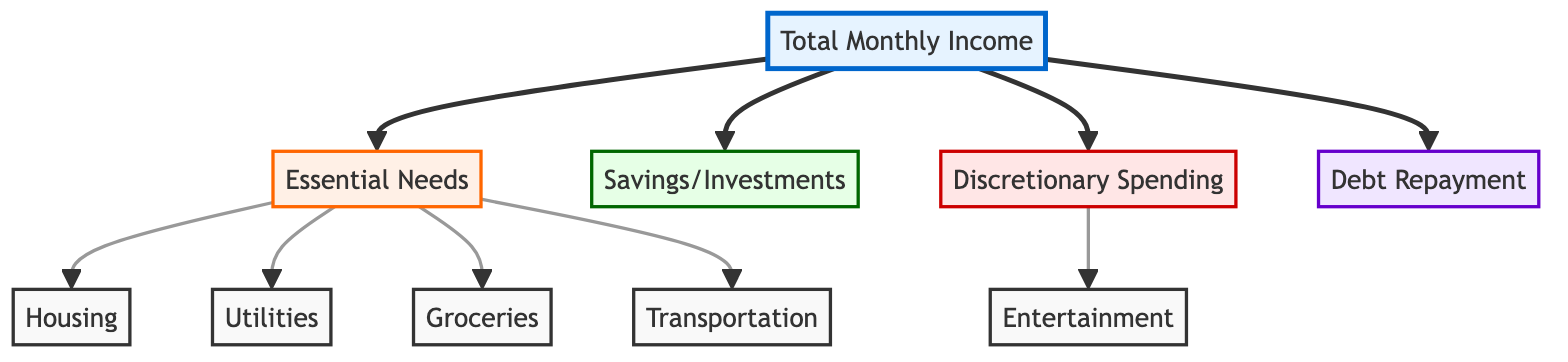What is the total number of nodes in this diagram? The diagram contains a total of 10 nodes, which are Total Monthly Income, Essential Needs, Housing, Utilities, Groceries, Transportation, Savings/Investments, Discretionary Spending, Entertainment, and Debt Repayment.
Answer: 10 Which node indicates essential needs? The node labeled "Essential Needs" represents the basic necessity category for household expenses. In the diagram, it is directly connected to Total Monthly Income.
Answer: Essential Needs How many edges are connected to the "Income" node? The "Income" node has 4 edges connected to it, leading to the nodes "Needs," "Savings," "Discretionary," and "Debt." This indicates the different allocations of income.
Answer: 4 What node is directly connected to "Discretionary Spending"? The node "Entertainment" is directly connected to "Discretionary Spending," displaying that entertainment expenses fall under this discretionary category.
Answer: Entertainment What type of spending does the "Housing" node represent? The "Housing" node represents essential need spending for household financial planning, specifically in terms of rent or mortgage payments.
Answer: Housing Which two nodes have a direct relationship indicating a breakdown of needs? The nodes "Essential Needs" and "Housing" have a direct relationship, with "Housing" categorized under "Essential Needs," showing that housing costs are an essential need.
Answer: Essential Needs and Housing What is the direction of flow from "Income" to "Savings"? The direction of flow from "Income" to "Savings" is depicted with an arrow starting from "Income" pointing towards "Savings," demonstrating that a portion of income goes towards savings.
Answer: Income to Savings Which node represents non-essential spending? The node labeled "Discretionary Spending" represents non-essential spending, indicating expenses that are not critical to daily living.
Answer: Discretionary Spending 